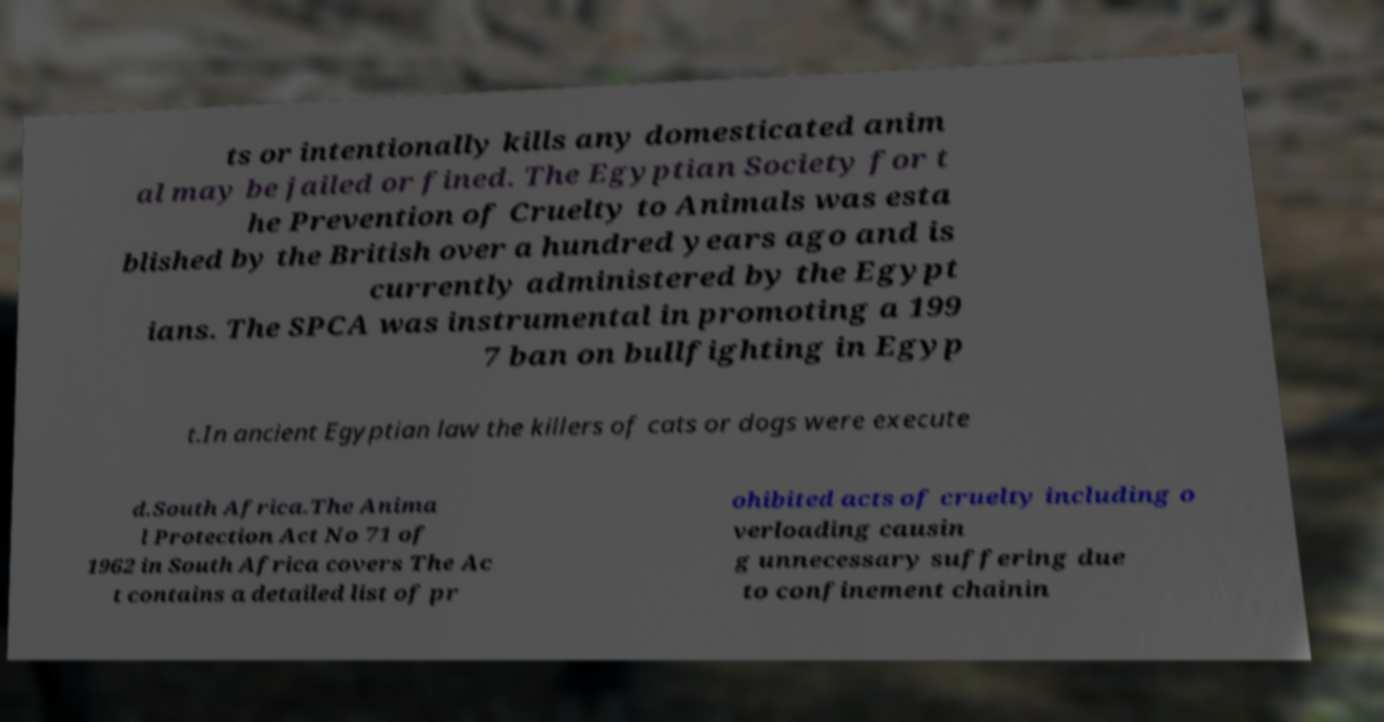What messages or text are displayed in this image? I need them in a readable, typed format. ts or intentionally kills any domesticated anim al may be jailed or fined. The Egyptian Society for t he Prevention of Cruelty to Animals was esta blished by the British over a hundred years ago and is currently administered by the Egypt ians. The SPCA was instrumental in promoting a 199 7 ban on bullfighting in Egyp t.In ancient Egyptian law the killers of cats or dogs were execute d.South Africa.The Anima l Protection Act No 71 of 1962 in South Africa covers The Ac t contains a detailed list of pr ohibited acts of cruelty including o verloading causin g unnecessary suffering due to confinement chainin 